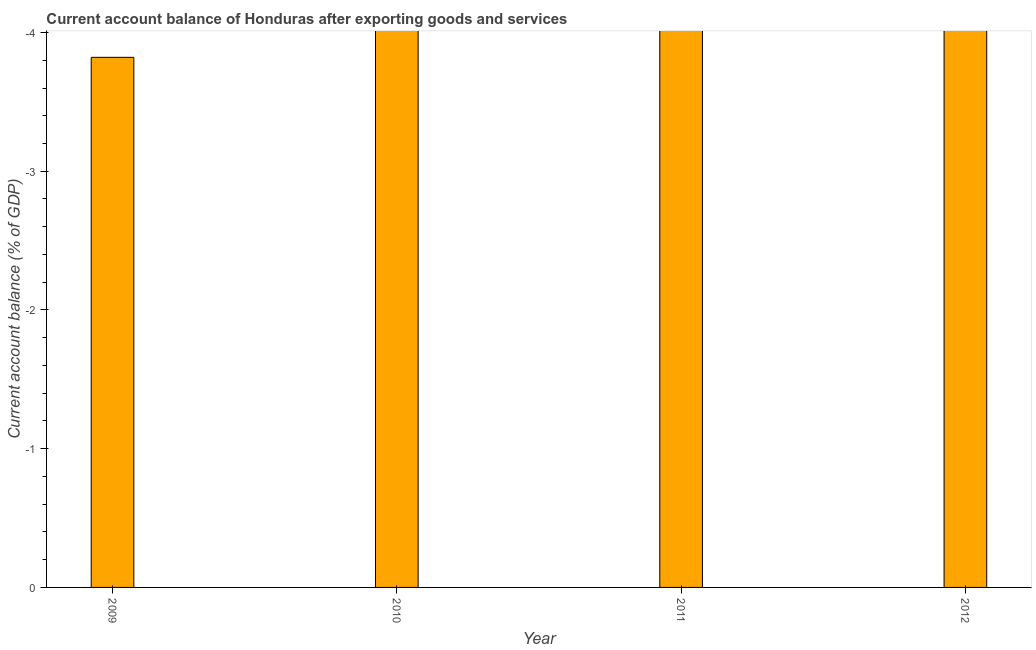What is the title of the graph?
Your answer should be compact. Current account balance of Honduras after exporting goods and services. What is the label or title of the Y-axis?
Keep it short and to the point. Current account balance (% of GDP). What is the current account balance in 2012?
Offer a terse response. 0. What is the sum of the current account balance?
Provide a succinct answer. 0. What is the median current account balance?
Ensure brevity in your answer.  0. In how many years, is the current account balance greater than the average current account balance taken over all years?
Ensure brevity in your answer.  0. What is the difference between two consecutive major ticks on the Y-axis?
Your answer should be very brief. 1. What is the Current account balance (% of GDP) of 2009?
Your answer should be compact. 0. What is the Current account balance (% of GDP) in 2010?
Keep it short and to the point. 0. What is the Current account balance (% of GDP) of 2011?
Offer a very short reply. 0. What is the Current account balance (% of GDP) of 2012?
Your answer should be compact. 0. 